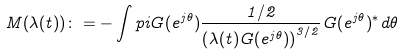<formula> <loc_0><loc_0><loc_500><loc_500>M ( \lambda ( t ) ) \colon = - \int p i G ( e ^ { j \theta } ) \frac { 1 / 2 } { \left ( \lambda ( t ) G ( e ^ { j \theta } ) \right ) ^ { 3 / 2 } } G ( e ^ { j \theta } ) ^ { * } d \theta</formula> 